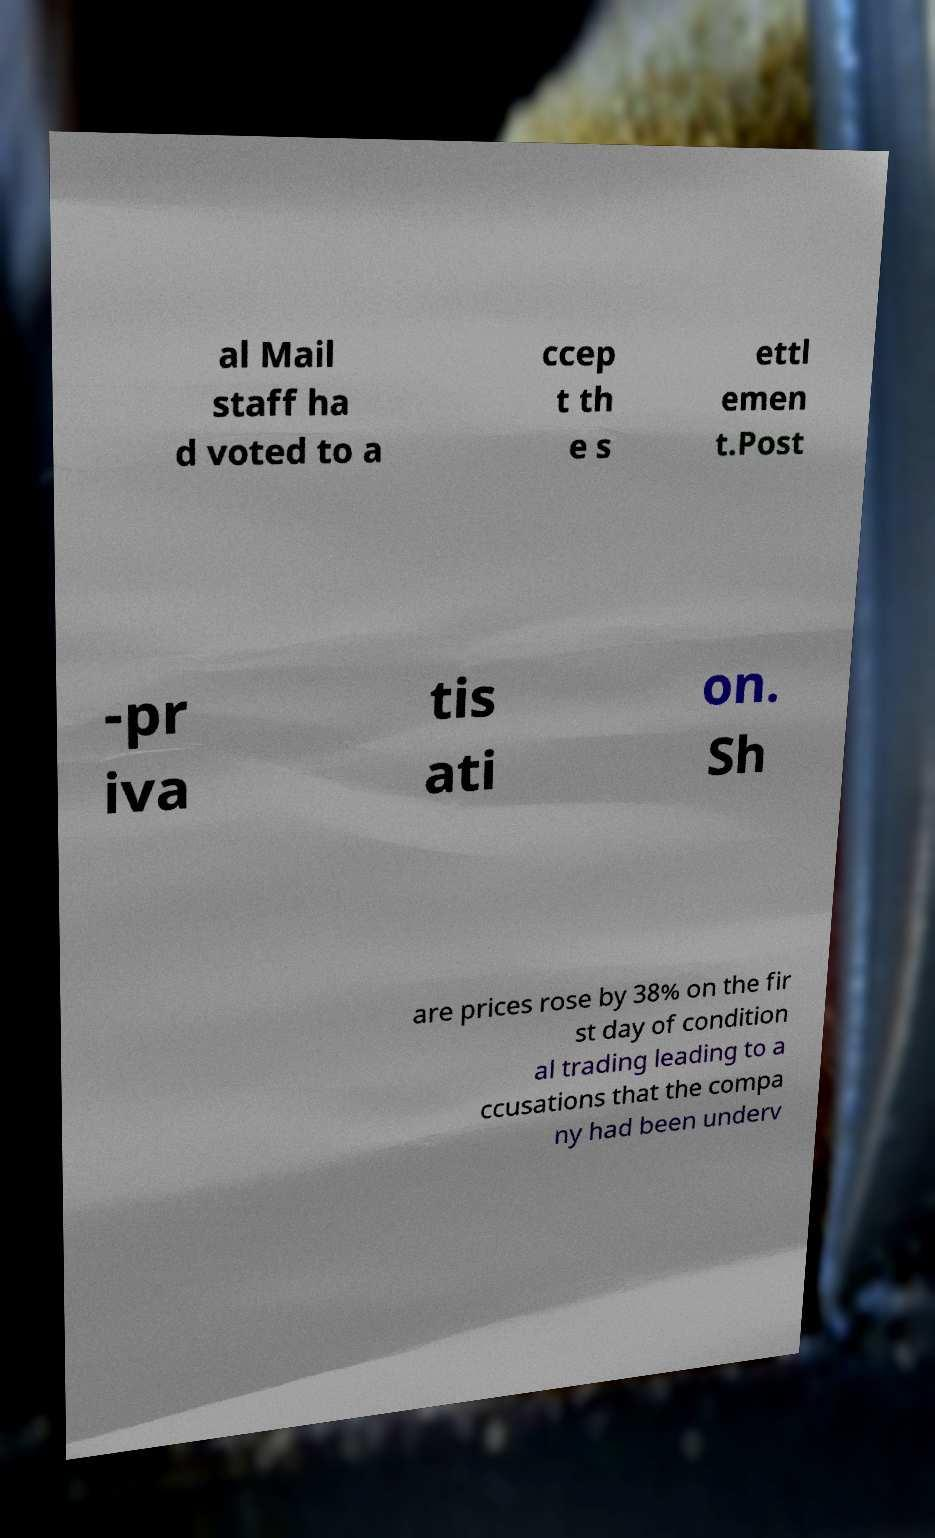There's text embedded in this image that I need extracted. Can you transcribe it verbatim? al Mail staff ha d voted to a ccep t th e s ettl emen t.Post -pr iva tis ati on. Sh are prices rose by 38% on the fir st day of condition al trading leading to a ccusations that the compa ny had been underv 